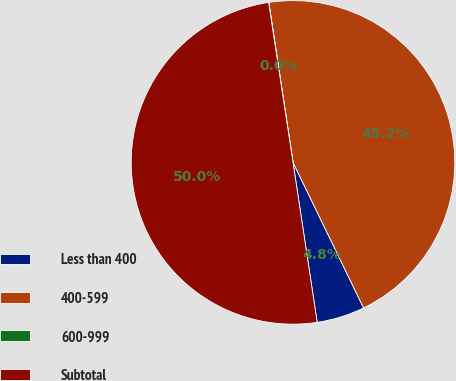Convert chart to OTSL. <chart><loc_0><loc_0><loc_500><loc_500><pie_chart><fcel>Less than 400<fcel>400-599<fcel>600-999<fcel>Subtotal<nl><fcel>4.8%<fcel>45.2%<fcel>0.02%<fcel>49.98%<nl></chart> 